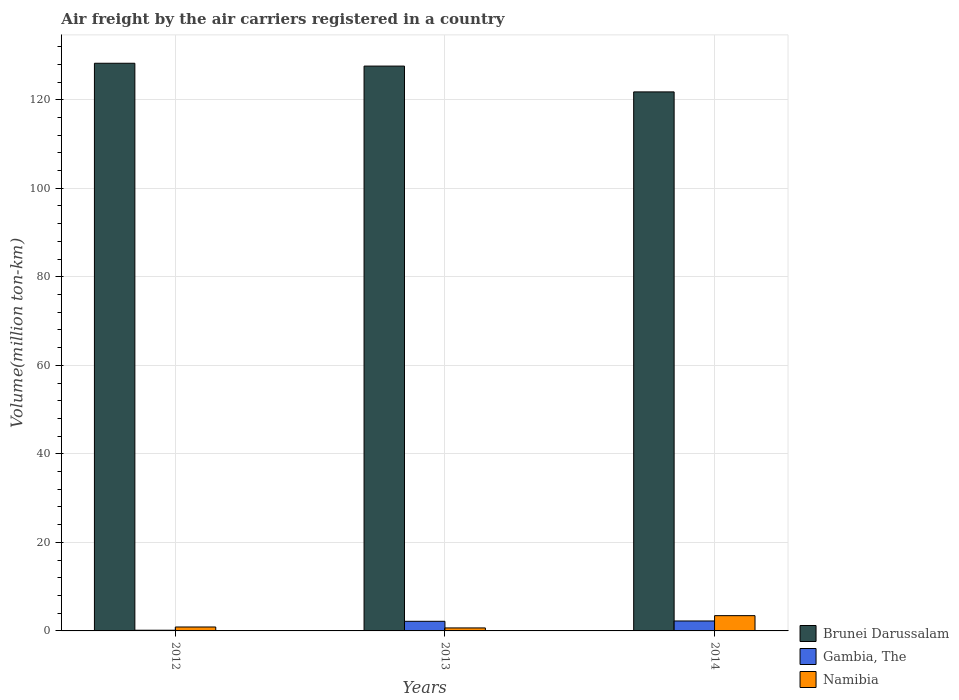How many different coloured bars are there?
Offer a terse response. 3. Are the number of bars per tick equal to the number of legend labels?
Offer a very short reply. Yes. How many bars are there on the 3rd tick from the left?
Give a very brief answer. 3. What is the volume of the air carriers in Brunei Darussalam in 2014?
Provide a succinct answer. 121.76. Across all years, what is the maximum volume of the air carriers in Brunei Darussalam?
Offer a terse response. 128.23. Across all years, what is the minimum volume of the air carriers in Brunei Darussalam?
Offer a terse response. 121.76. In which year was the volume of the air carriers in Namibia maximum?
Offer a terse response. 2014. What is the total volume of the air carriers in Namibia in the graph?
Your answer should be very brief. 5.02. What is the difference between the volume of the air carriers in Namibia in 2012 and that in 2014?
Make the answer very short. -2.56. What is the difference between the volume of the air carriers in Gambia, The in 2014 and the volume of the air carriers in Namibia in 2012?
Your answer should be very brief. 1.36. What is the average volume of the air carriers in Namibia per year?
Offer a very short reply. 1.67. In the year 2012, what is the difference between the volume of the air carriers in Namibia and volume of the air carriers in Brunei Darussalam?
Ensure brevity in your answer.  -127.35. In how many years, is the volume of the air carriers in Namibia greater than 20 million ton-km?
Provide a succinct answer. 0. What is the ratio of the volume of the air carriers in Namibia in 2012 to that in 2014?
Provide a succinct answer. 0.26. Is the volume of the air carriers in Gambia, The in 2012 less than that in 2013?
Provide a succinct answer. Yes. Is the difference between the volume of the air carriers in Namibia in 2013 and 2014 greater than the difference between the volume of the air carriers in Brunei Darussalam in 2013 and 2014?
Ensure brevity in your answer.  No. What is the difference between the highest and the second highest volume of the air carriers in Namibia?
Offer a very short reply. 2.56. What is the difference between the highest and the lowest volume of the air carriers in Brunei Darussalam?
Your answer should be compact. 6.47. In how many years, is the volume of the air carriers in Namibia greater than the average volume of the air carriers in Namibia taken over all years?
Give a very brief answer. 1. Is the sum of the volume of the air carriers in Brunei Darussalam in 2012 and 2013 greater than the maximum volume of the air carriers in Gambia, The across all years?
Your answer should be compact. Yes. What does the 3rd bar from the left in 2013 represents?
Provide a succinct answer. Namibia. What does the 3rd bar from the right in 2013 represents?
Your response must be concise. Brunei Darussalam. How many years are there in the graph?
Keep it short and to the point. 3. What is the difference between two consecutive major ticks on the Y-axis?
Provide a succinct answer. 20. Does the graph contain any zero values?
Ensure brevity in your answer.  No. Does the graph contain grids?
Your answer should be very brief. Yes. Where does the legend appear in the graph?
Give a very brief answer. Bottom right. How many legend labels are there?
Your answer should be very brief. 3. What is the title of the graph?
Provide a short and direct response. Air freight by the air carriers registered in a country. What is the label or title of the X-axis?
Make the answer very short. Years. What is the label or title of the Y-axis?
Make the answer very short. Volume(million ton-km). What is the Volume(million ton-km) in Brunei Darussalam in 2012?
Provide a succinct answer. 128.23. What is the Volume(million ton-km) of Gambia, The in 2012?
Offer a very short reply. 0.16. What is the Volume(million ton-km) of Namibia in 2012?
Keep it short and to the point. 0.89. What is the Volume(million ton-km) in Brunei Darussalam in 2013?
Make the answer very short. 127.59. What is the Volume(million ton-km) in Gambia, The in 2013?
Your response must be concise. 2.17. What is the Volume(million ton-km) of Namibia in 2013?
Your answer should be very brief. 0.68. What is the Volume(million ton-km) of Brunei Darussalam in 2014?
Your response must be concise. 121.76. What is the Volume(million ton-km) in Gambia, The in 2014?
Offer a terse response. 2.25. What is the Volume(million ton-km) of Namibia in 2014?
Give a very brief answer. 3.45. Across all years, what is the maximum Volume(million ton-km) in Brunei Darussalam?
Provide a succinct answer. 128.23. Across all years, what is the maximum Volume(million ton-km) of Gambia, The?
Ensure brevity in your answer.  2.25. Across all years, what is the maximum Volume(million ton-km) in Namibia?
Provide a short and direct response. 3.45. Across all years, what is the minimum Volume(million ton-km) of Brunei Darussalam?
Make the answer very short. 121.76. Across all years, what is the minimum Volume(million ton-km) in Gambia, The?
Provide a succinct answer. 0.16. Across all years, what is the minimum Volume(million ton-km) of Namibia?
Make the answer very short. 0.68. What is the total Volume(million ton-km) in Brunei Darussalam in the graph?
Make the answer very short. 377.59. What is the total Volume(million ton-km) in Gambia, The in the graph?
Your answer should be compact. 4.57. What is the total Volume(million ton-km) in Namibia in the graph?
Keep it short and to the point. 5.02. What is the difference between the Volume(million ton-km) of Brunei Darussalam in 2012 and that in 2013?
Your answer should be compact. 0.64. What is the difference between the Volume(million ton-km) in Gambia, The in 2012 and that in 2013?
Provide a succinct answer. -2.02. What is the difference between the Volume(million ton-km) of Namibia in 2012 and that in 2013?
Provide a succinct answer. 0.21. What is the difference between the Volume(million ton-km) of Brunei Darussalam in 2012 and that in 2014?
Your answer should be compact. 6.47. What is the difference between the Volume(million ton-km) in Gambia, The in 2012 and that in 2014?
Your answer should be very brief. -2.09. What is the difference between the Volume(million ton-km) of Namibia in 2012 and that in 2014?
Keep it short and to the point. -2.56. What is the difference between the Volume(million ton-km) in Brunei Darussalam in 2013 and that in 2014?
Keep it short and to the point. 5.83. What is the difference between the Volume(million ton-km) in Gambia, The in 2013 and that in 2014?
Your response must be concise. -0.07. What is the difference between the Volume(million ton-km) of Namibia in 2013 and that in 2014?
Offer a very short reply. -2.77. What is the difference between the Volume(million ton-km) of Brunei Darussalam in 2012 and the Volume(million ton-km) of Gambia, The in 2013?
Offer a very short reply. 126.06. What is the difference between the Volume(million ton-km) in Brunei Darussalam in 2012 and the Volume(million ton-km) in Namibia in 2013?
Offer a terse response. 127.56. What is the difference between the Volume(million ton-km) in Gambia, The in 2012 and the Volume(million ton-km) in Namibia in 2013?
Keep it short and to the point. -0.52. What is the difference between the Volume(million ton-km) of Brunei Darussalam in 2012 and the Volume(million ton-km) of Gambia, The in 2014?
Provide a short and direct response. 125.99. What is the difference between the Volume(million ton-km) of Brunei Darussalam in 2012 and the Volume(million ton-km) of Namibia in 2014?
Your answer should be very brief. 124.78. What is the difference between the Volume(million ton-km) in Gambia, The in 2012 and the Volume(million ton-km) in Namibia in 2014?
Give a very brief answer. -3.3. What is the difference between the Volume(million ton-km) of Brunei Darussalam in 2013 and the Volume(million ton-km) of Gambia, The in 2014?
Provide a succinct answer. 125.35. What is the difference between the Volume(million ton-km) in Brunei Darussalam in 2013 and the Volume(million ton-km) in Namibia in 2014?
Offer a terse response. 124.14. What is the difference between the Volume(million ton-km) of Gambia, The in 2013 and the Volume(million ton-km) of Namibia in 2014?
Keep it short and to the point. -1.28. What is the average Volume(million ton-km) in Brunei Darussalam per year?
Your answer should be compact. 125.86. What is the average Volume(million ton-km) in Gambia, The per year?
Your response must be concise. 1.52. What is the average Volume(million ton-km) in Namibia per year?
Ensure brevity in your answer.  1.67. In the year 2012, what is the difference between the Volume(million ton-km) of Brunei Darussalam and Volume(million ton-km) of Gambia, The?
Offer a very short reply. 128.08. In the year 2012, what is the difference between the Volume(million ton-km) of Brunei Darussalam and Volume(million ton-km) of Namibia?
Offer a very short reply. 127.35. In the year 2012, what is the difference between the Volume(million ton-km) in Gambia, The and Volume(million ton-km) in Namibia?
Offer a very short reply. -0.73. In the year 2013, what is the difference between the Volume(million ton-km) of Brunei Darussalam and Volume(million ton-km) of Gambia, The?
Provide a short and direct response. 125.42. In the year 2013, what is the difference between the Volume(million ton-km) of Brunei Darussalam and Volume(million ton-km) of Namibia?
Keep it short and to the point. 126.92. In the year 2013, what is the difference between the Volume(million ton-km) of Gambia, The and Volume(million ton-km) of Namibia?
Your answer should be very brief. 1.49. In the year 2014, what is the difference between the Volume(million ton-km) of Brunei Darussalam and Volume(million ton-km) of Gambia, The?
Give a very brief answer. 119.52. In the year 2014, what is the difference between the Volume(million ton-km) of Brunei Darussalam and Volume(million ton-km) of Namibia?
Give a very brief answer. 118.31. In the year 2014, what is the difference between the Volume(million ton-km) in Gambia, The and Volume(million ton-km) in Namibia?
Your answer should be very brief. -1.21. What is the ratio of the Volume(million ton-km) of Brunei Darussalam in 2012 to that in 2013?
Your response must be concise. 1. What is the ratio of the Volume(million ton-km) in Gambia, The in 2012 to that in 2013?
Provide a short and direct response. 0.07. What is the ratio of the Volume(million ton-km) in Namibia in 2012 to that in 2013?
Offer a terse response. 1.31. What is the ratio of the Volume(million ton-km) of Brunei Darussalam in 2012 to that in 2014?
Give a very brief answer. 1.05. What is the ratio of the Volume(million ton-km) in Gambia, The in 2012 to that in 2014?
Ensure brevity in your answer.  0.07. What is the ratio of the Volume(million ton-km) of Namibia in 2012 to that in 2014?
Your answer should be very brief. 0.26. What is the ratio of the Volume(million ton-km) in Brunei Darussalam in 2013 to that in 2014?
Offer a terse response. 1.05. What is the ratio of the Volume(million ton-km) in Gambia, The in 2013 to that in 2014?
Give a very brief answer. 0.97. What is the ratio of the Volume(million ton-km) in Namibia in 2013 to that in 2014?
Provide a succinct answer. 0.2. What is the difference between the highest and the second highest Volume(million ton-km) of Brunei Darussalam?
Keep it short and to the point. 0.64. What is the difference between the highest and the second highest Volume(million ton-km) of Gambia, The?
Give a very brief answer. 0.07. What is the difference between the highest and the second highest Volume(million ton-km) in Namibia?
Offer a terse response. 2.56. What is the difference between the highest and the lowest Volume(million ton-km) in Brunei Darussalam?
Keep it short and to the point. 6.47. What is the difference between the highest and the lowest Volume(million ton-km) of Gambia, The?
Offer a terse response. 2.09. What is the difference between the highest and the lowest Volume(million ton-km) of Namibia?
Keep it short and to the point. 2.77. 